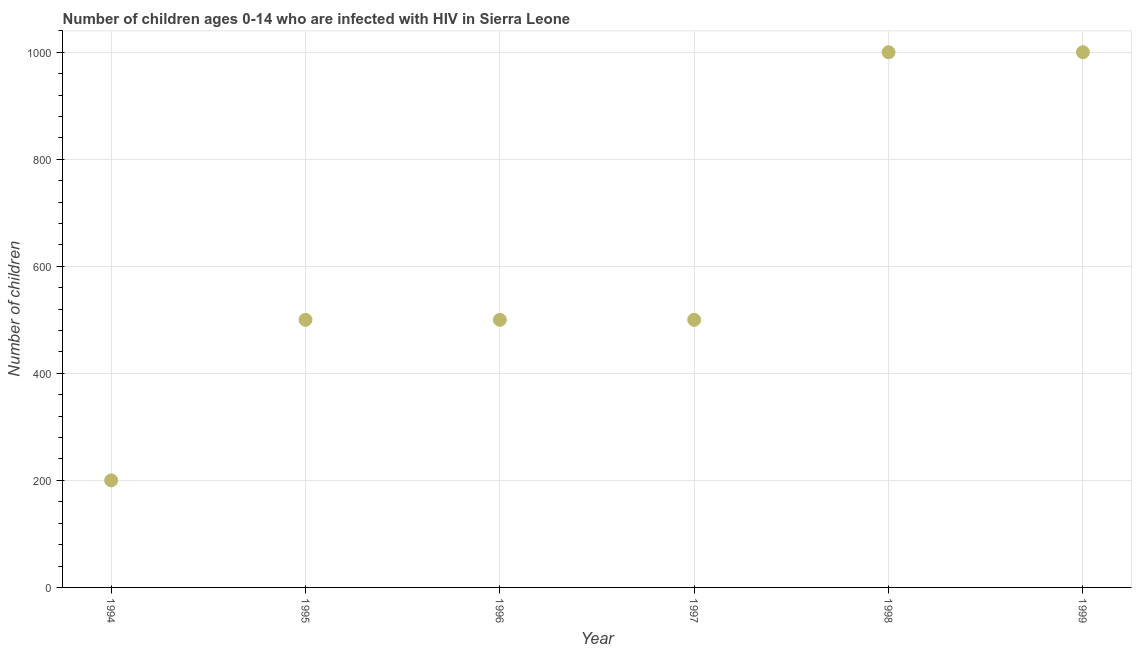What is the number of children living with hiv in 1998?
Give a very brief answer. 1000. Across all years, what is the maximum number of children living with hiv?
Offer a very short reply. 1000. Across all years, what is the minimum number of children living with hiv?
Provide a short and direct response. 200. In which year was the number of children living with hiv maximum?
Provide a succinct answer. 1998. In which year was the number of children living with hiv minimum?
Make the answer very short. 1994. What is the sum of the number of children living with hiv?
Make the answer very short. 3700. What is the difference between the number of children living with hiv in 1997 and 1999?
Make the answer very short. -500. What is the average number of children living with hiv per year?
Your answer should be compact. 616.67. What is the median number of children living with hiv?
Provide a succinct answer. 500. Is the number of children living with hiv in 1997 less than that in 1999?
Keep it short and to the point. Yes. What is the difference between the highest and the second highest number of children living with hiv?
Offer a very short reply. 0. Is the sum of the number of children living with hiv in 1996 and 1999 greater than the maximum number of children living with hiv across all years?
Your answer should be compact. Yes. What is the difference between the highest and the lowest number of children living with hiv?
Ensure brevity in your answer.  800. In how many years, is the number of children living with hiv greater than the average number of children living with hiv taken over all years?
Provide a short and direct response. 2. Does the number of children living with hiv monotonically increase over the years?
Give a very brief answer. No. How many dotlines are there?
Offer a terse response. 1. What is the difference between two consecutive major ticks on the Y-axis?
Offer a very short reply. 200. Does the graph contain grids?
Your answer should be very brief. Yes. What is the title of the graph?
Offer a terse response. Number of children ages 0-14 who are infected with HIV in Sierra Leone. What is the label or title of the Y-axis?
Offer a very short reply. Number of children. What is the Number of children in 1994?
Keep it short and to the point. 200. What is the Number of children in 1996?
Your response must be concise. 500. What is the Number of children in 1997?
Give a very brief answer. 500. What is the Number of children in 1998?
Your answer should be very brief. 1000. What is the difference between the Number of children in 1994 and 1995?
Your response must be concise. -300. What is the difference between the Number of children in 1994 and 1996?
Your answer should be very brief. -300. What is the difference between the Number of children in 1994 and 1997?
Your answer should be very brief. -300. What is the difference between the Number of children in 1994 and 1998?
Your answer should be compact. -800. What is the difference between the Number of children in 1994 and 1999?
Offer a terse response. -800. What is the difference between the Number of children in 1995 and 1996?
Ensure brevity in your answer.  0. What is the difference between the Number of children in 1995 and 1998?
Your answer should be compact. -500. What is the difference between the Number of children in 1995 and 1999?
Keep it short and to the point. -500. What is the difference between the Number of children in 1996 and 1998?
Provide a succinct answer. -500. What is the difference between the Number of children in 1996 and 1999?
Your answer should be compact. -500. What is the difference between the Number of children in 1997 and 1998?
Your response must be concise. -500. What is the difference between the Number of children in 1997 and 1999?
Give a very brief answer. -500. What is the ratio of the Number of children in 1994 to that in 1996?
Your response must be concise. 0.4. What is the ratio of the Number of children in 1995 to that in 1996?
Your response must be concise. 1. What is the ratio of the Number of children in 1996 to that in 1997?
Give a very brief answer. 1. What is the ratio of the Number of children in 1997 to that in 1998?
Ensure brevity in your answer.  0.5. What is the ratio of the Number of children in 1998 to that in 1999?
Give a very brief answer. 1. 